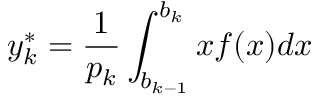<formula> <loc_0><loc_0><loc_500><loc_500>y _ { k } ^ { * } = { \frac { 1 } { p _ { k } } } \int _ { b _ { k - 1 } } ^ { b _ { k } } x f ( x ) d x</formula> 